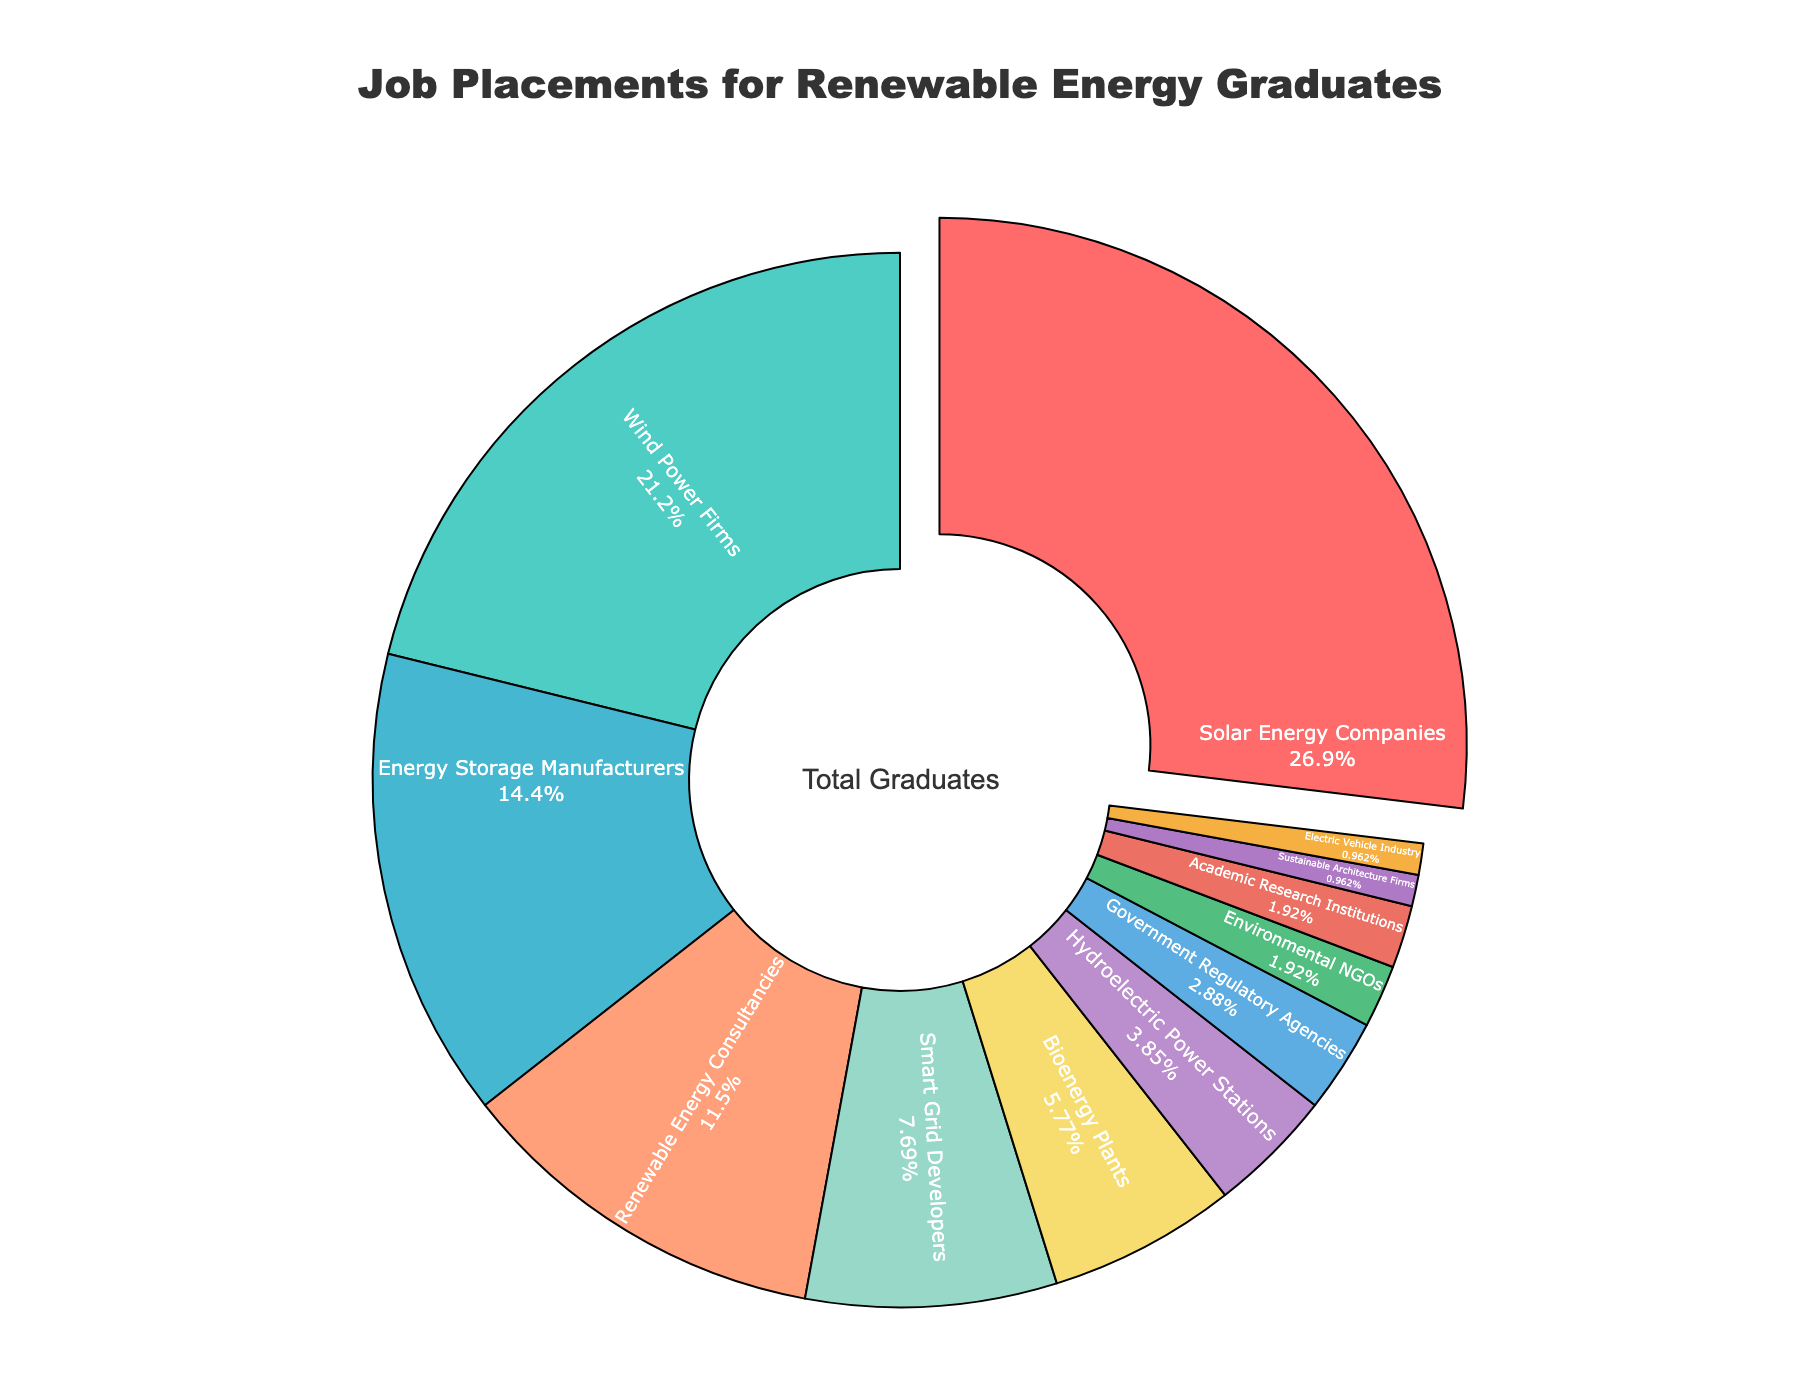Which sector employs the highest percentage of renewable energy graduates? The sector with the largest visual segment in the pie chart represents the highest employment percentage. In this chart, that sector is Solar Energy Companies.
Answer: Solar Energy Companies Which two sectors together account for the largest proportion of job placements? Identify the two largest segments of the pie chart. The highest and second-highest segments represent the largest combined proportion. The largest is Solar Energy Companies at 28% and the second largest is Wind Power Firms at 22%, adding up to 50%.
Answer: Solar Energy Companies and Wind Power Firms How does the percentage of job placements in Smart Grid Developers compare to that in Energy Storage Manufacturers? Locate the two segments of interest: Smart Grid Developers and Energy Storage Manufacturers. Smart Grid Developers employ 8% and Energy Storage Manufacturers employ 15%, so Smart Grid Developers employ a lesser percentage.
Answer: Smart Grid Developers employ less than Energy Storage Manufacturers What is the combined percentage of graduates working in government regulatory agencies, environmental NGOs, and academic research institutions? Add up the percentages for Government Regulatory Agencies (3%), Environmental NGOs (2%), and Academic Research Institutions (2%). The sum is 3% + 2% + 2% = 7%.
Answer: 7% Which sector has the smallest share of job placements for renewable energy graduates? Identify the smallest segment in the pie chart. The smallest sector is Sustainable Architecture Firms, with 1% of job placements.
Answer: Sustainable Architecture Firms How much larger is the percentage of graduates in Renewable Energy Consultancies compared to Bioenergy Plants? Locate the segments for Renewable Energy Consultancies (12%) and Bioenergy Plants (6%), then calculate the difference. 12% - 6% = 6%.
Answer: 6% larger What sectors have an equal percentage of job placements? Identify sectors with the same visual segment size or percentage. Both Academic Research Institutions and Electric Vehicle Industry have 2%.
Answer: Academic Research Institutions and Electric Vehicle Industry What is the total percentage of graduates employed in sectors related to direct energy production (Solar Energy Companies, Wind Power Firms, Bioenergy Plants, and Hydroelectric Power Stations)? Add the percentages for direct energy production sectors: Solar Energy Companies (28%), Wind Power Firms (22%), Bioenergy Plants (6%), and Hydroelectric Power Stations (4%). The sum is 28% + 22% + 6% + 4% = 60%.
Answer: 60% Compare the employment percentage of Renewable Energy Consultancies to Smart Grid Developers and explain the difference. Identify the segments for Renewable Energy Consultancies (12%) and Smart Grid Developers (8%). Calculate the difference: 12% - 8% = 4%.
Answer: Renewable Energy Consultancies employ 4% more graduates than Smart Grid Developers What is the dominant color in the pie chart and which sector does it represent? The dominant color in the pie chart is the one with the largest segment. The segment for Solar Energy Companies is the largest and it is colored red.
Answer: Red, representing Solar Energy Companies 